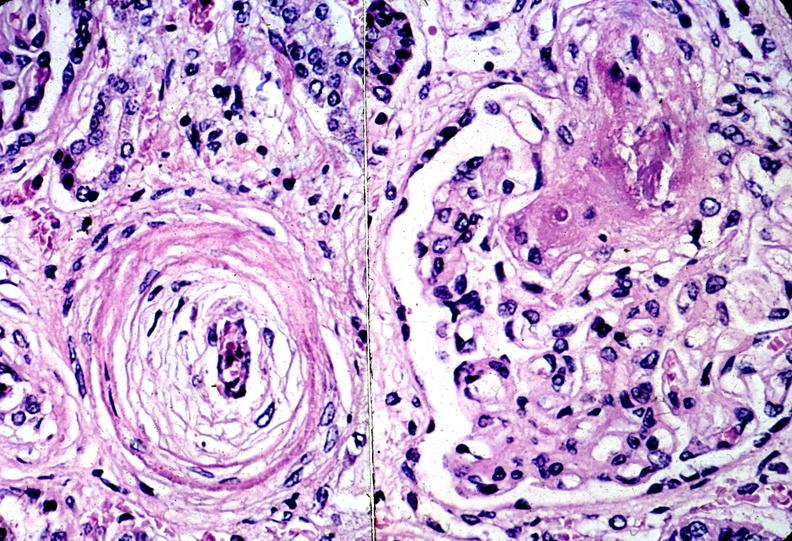does this image show kidney, arteriolonephrosclerosis, malignant hypertension?
Answer the question using a single word or phrase. Yes 